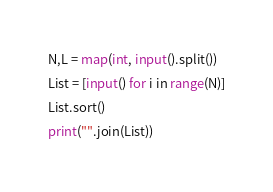<code> <loc_0><loc_0><loc_500><loc_500><_Python_>N,L = map(int, input().split())
List = [input() for i in range(N)]
List.sort()
print("".join(List))</code> 